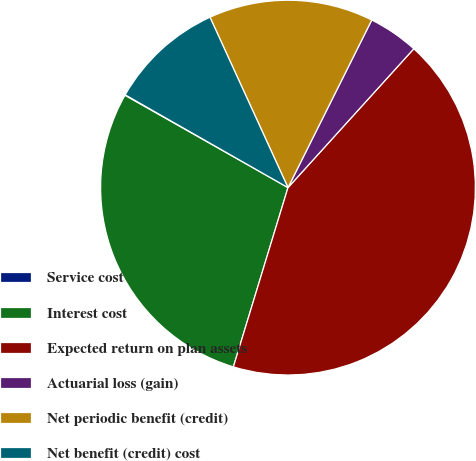Convert chart to OTSL. <chart><loc_0><loc_0><loc_500><loc_500><pie_chart><fcel>Service cost<fcel>Interest cost<fcel>Expected return on plan assets<fcel>Actuarial loss (gain)<fcel>Net periodic benefit (credit)<fcel>Net benefit (credit) cost<nl><fcel>0.05%<fcel>28.49%<fcel>42.99%<fcel>4.34%<fcel>14.21%<fcel>9.92%<nl></chart> 